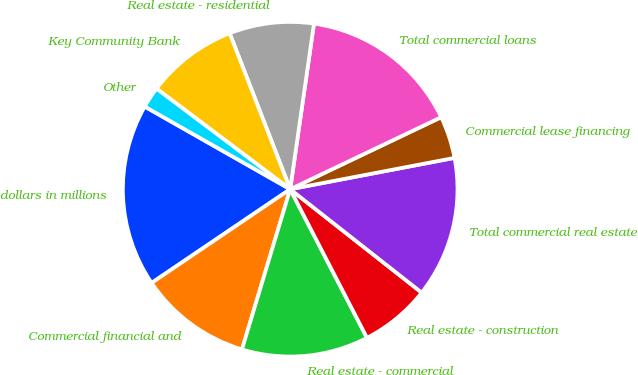Convert chart to OTSL. <chart><loc_0><loc_0><loc_500><loc_500><pie_chart><fcel>dollars in millions<fcel>Commercial financial and<fcel>Real estate - commercial<fcel>Real estate - construction<fcel>Total commercial real estate<fcel>Commercial lease financing<fcel>Total commercial loans<fcel>Real estate - residential<fcel>Key Community Bank<fcel>Other<nl><fcel>17.68%<fcel>10.88%<fcel>12.24%<fcel>6.8%<fcel>13.6%<fcel>4.08%<fcel>15.64%<fcel>8.16%<fcel>8.84%<fcel>2.04%<nl></chart> 